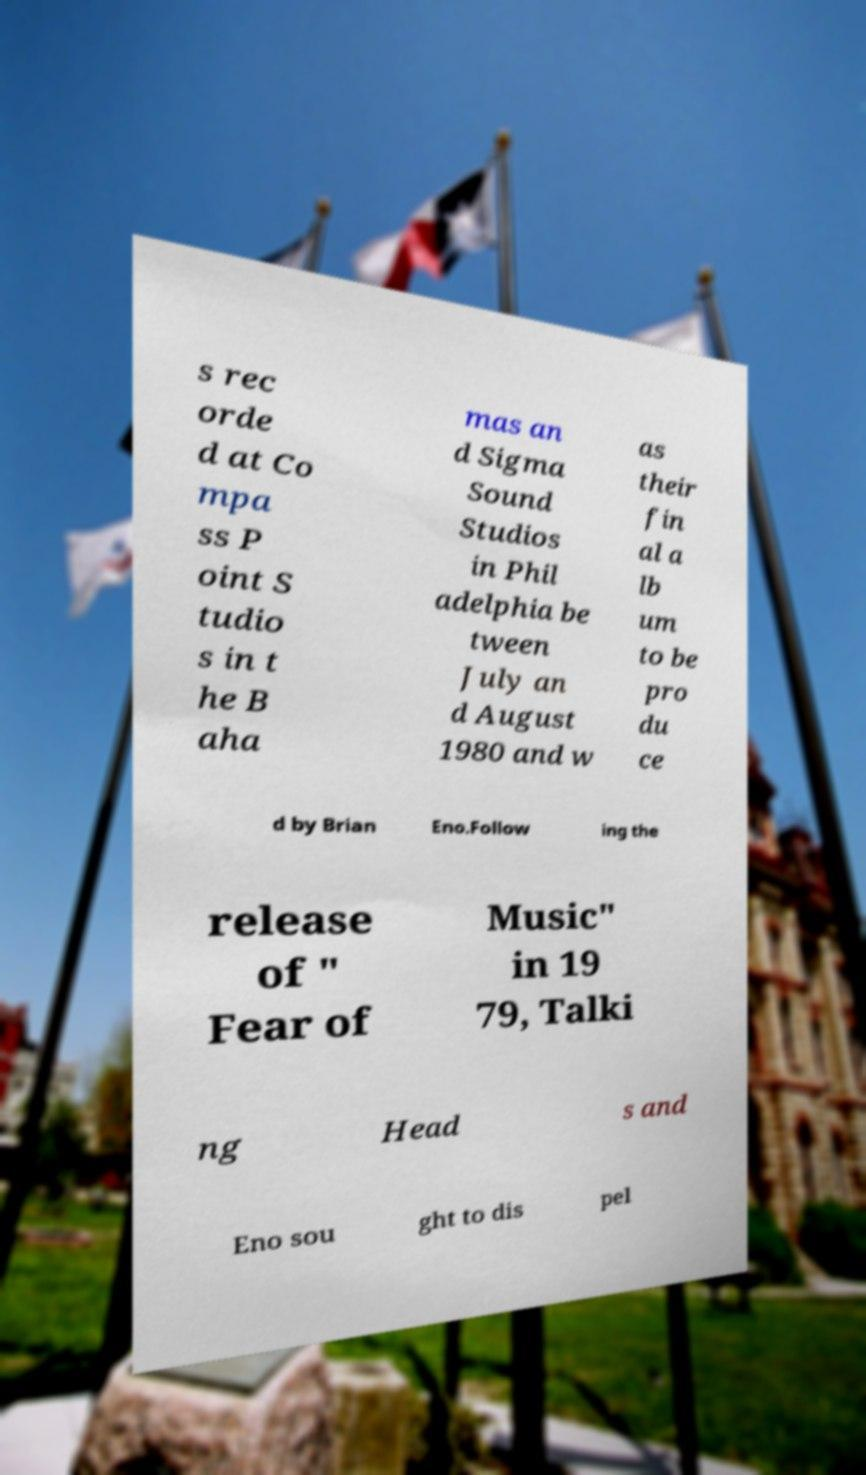Can you read and provide the text displayed in the image?This photo seems to have some interesting text. Can you extract and type it out for me? s rec orde d at Co mpa ss P oint S tudio s in t he B aha mas an d Sigma Sound Studios in Phil adelphia be tween July an d August 1980 and w as their fin al a lb um to be pro du ce d by Brian Eno.Follow ing the release of " Fear of Music" in 19 79, Talki ng Head s and Eno sou ght to dis pel 